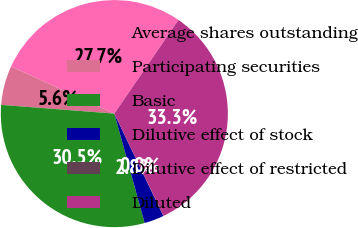Convert chart. <chart><loc_0><loc_0><loc_500><loc_500><pie_chart><fcel>Average shares outstanding<fcel>Participating securities<fcel>Basic<fcel>Dilutive effect of stock<fcel>Dilutive effect of restricted<fcel>Diluted<nl><fcel>27.74%<fcel>5.59%<fcel>30.53%<fcel>2.81%<fcel>0.02%<fcel>33.31%<nl></chart> 